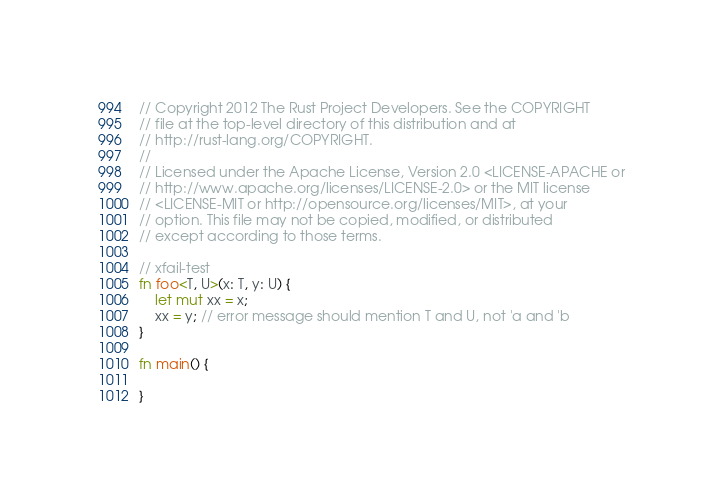Convert code to text. <code><loc_0><loc_0><loc_500><loc_500><_Rust_>// Copyright 2012 The Rust Project Developers. See the COPYRIGHT
// file at the top-level directory of this distribution and at
// http://rust-lang.org/COPYRIGHT.
//
// Licensed under the Apache License, Version 2.0 <LICENSE-APACHE or
// http://www.apache.org/licenses/LICENSE-2.0> or the MIT license
// <LICENSE-MIT or http://opensource.org/licenses/MIT>, at your
// option. This file may not be copied, modified, or distributed
// except according to those terms.

// xfail-test
fn foo<T, U>(x: T, y: U) {
    let mut xx = x;
    xx = y; // error message should mention T and U, not 'a and 'b
}

fn main() {
    
}
</code> 